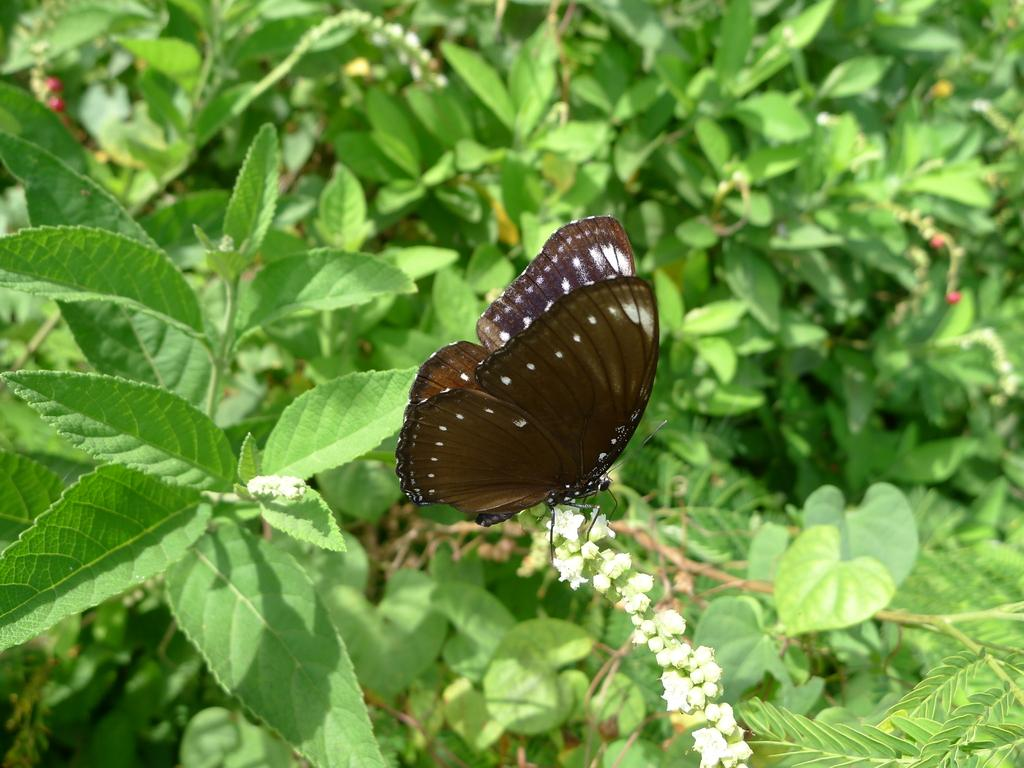What type of plant life is visible in the image? There are stems with leaves in the image. Are there any additional features on the stems? Yes, there are flowers on the stems. What can be seen on the flowers in the image? There is a butterfly on the flowers. What type of pear is hanging from the stems in the image? There are no pears present in the image; it features stems with leaves and flowers. Can you tell me how many horses are grazing on the flowers in the image? There are no horses present in the image; it features a butterfly on the flowers. 